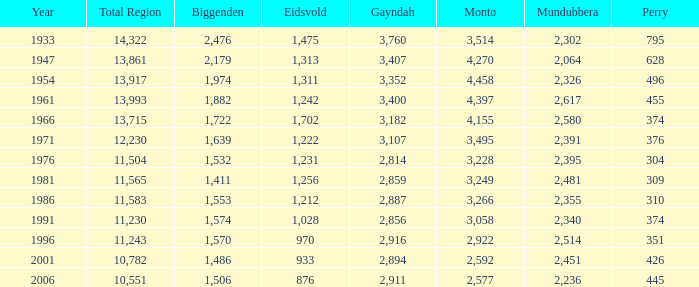Which is the year with Mundubbera being smaller than 2,395, and Biggenden smaller than 1,506? None. 